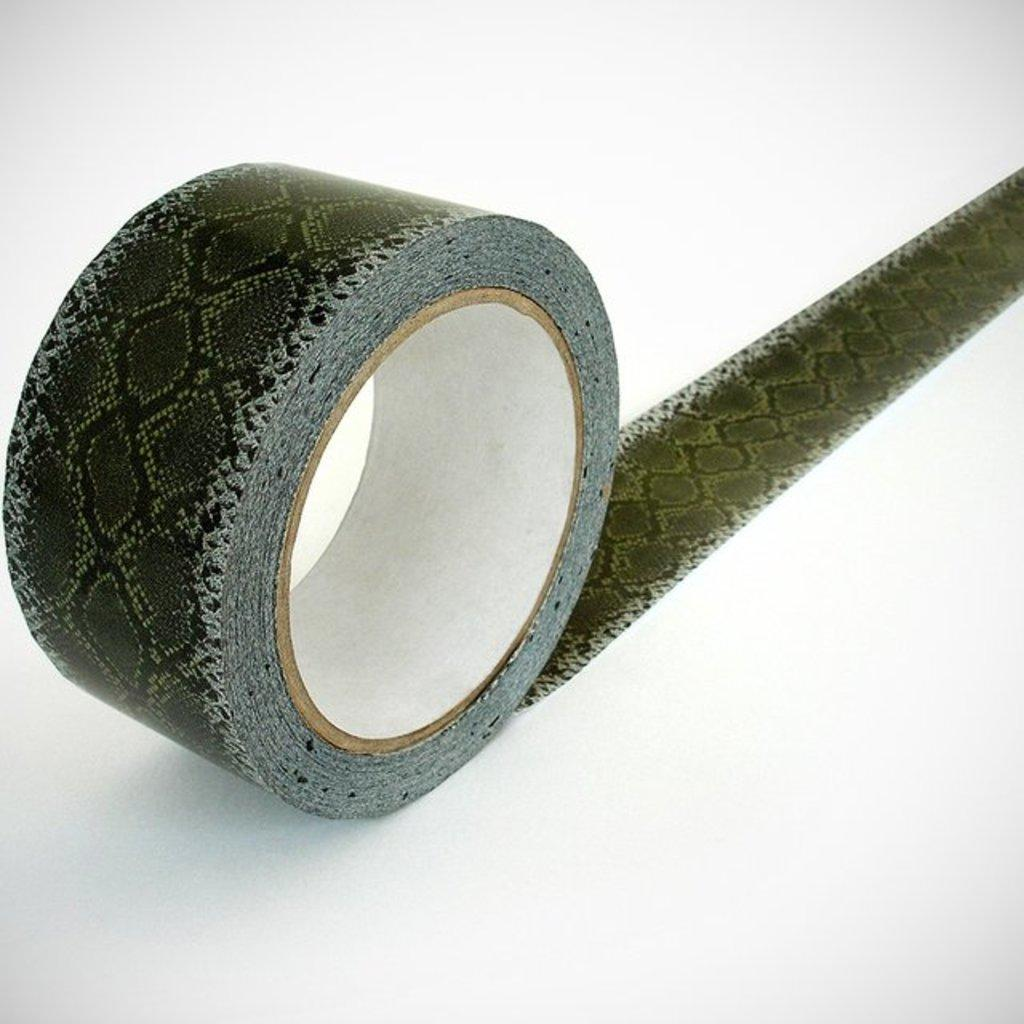What object is visible on the white surface in the image? There is a roll of tape in the image. Can you describe the surface on which the roll of tape is placed? The roll of tape is on a white surface. Reasoning: Let's think step by step by step in order to produce the conversation. We start by identifying the main subject in the image, which is the roll of tape. Then, we expand the conversation to include the surface on which the roll of tape is placed. Each question is designed to elicit a specific detail about the image that is known from the provided facts. Absurd Question/Answer: How many sheep can be seen grazing near the roll of tape in the image? There are no sheep present in the image; it only features a roll of tape on a white surface. Can you tell me how many giraffes are visible in the image? There are no giraffes present in the image; it only features a roll of tape on a white surface. 